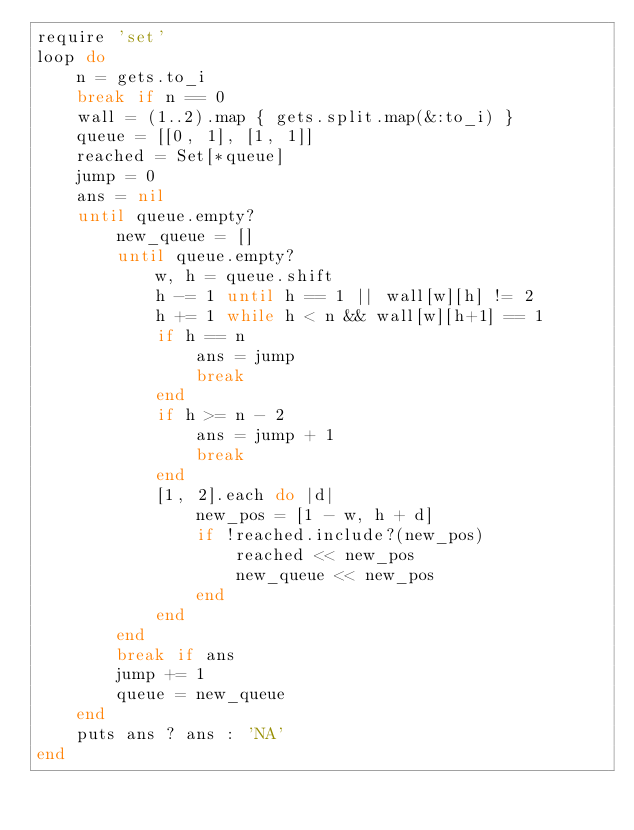Convert code to text. <code><loc_0><loc_0><loc_500><loc_500><_Ruby_>require 'set'
loop do
    n = gets.to_i
    break if n == 0
    wall = (1..2).map { gets.split.map(&:to_i) }
    queue = [[0, 1], [1, 1]]
    reached = Set[*queue]
    jump = 0
    ans = nil
    until queue.empty?
        new_queue = []
        until queue.empty?
            w, h = queue.shift
            h -= 1 until h == 1 || wall[w][h] != 2
            h += 1 while h < n && wall[w][h+1] == 1
            if h == n
                ans = jump
                break
            end
            if h >= n - 2
                ans = jump + 1
                break
            end
            [1, 2].each do |d|
                new_pos = [1 - w, h + d]
                if !reached.include?(new_pos)
                    reached << new_pos
                    new_queue << new_pos
                end
            end
        end
        break if ans
        jump += 1
        queue = new_queue
    end
    puts ans ? ans : 'NA'
end

</code> 